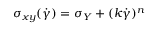<formula> <loc_0><loc_0><loc_500><loc_500>\sigma _ { x y } ( \dot { \gamma } ) = \sigma _ { Y } + ( k \dot { \gamma } ) ^ { n }</formula> 